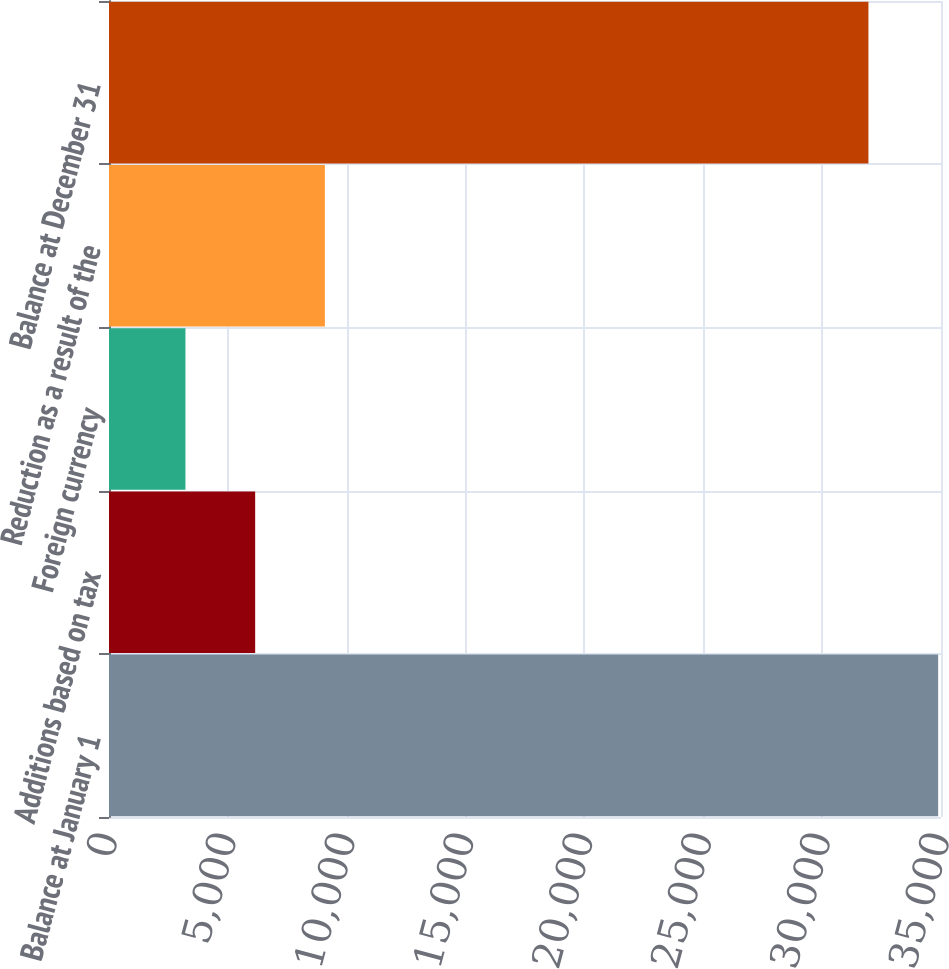Convert chart. <chart><loc_0><loc_0><loc_500><loc_500><bar_chart><fcel>Balance at January 1<fcel>Additions based on tax<fcel>Foreign currency<fcel>Reduction as a result of the<fcel>Balance at December 31<nl><fcel>34879.9<fcel>6148.9<fcel>3216<fcel>9081.8<fcel>31947<nl></chart> 